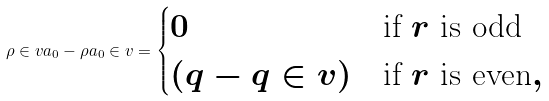<formula> <loc_0><loc_0><loc_500><loc_500>\rho \in v a _ { 0 } - \rho a _ { 0 } \in v = \begin{cases} 0 & \text {if $r$ is odd} \\ ( q - q \in v ) & \text {if $r$ is even} , \end{cases}</formula> 